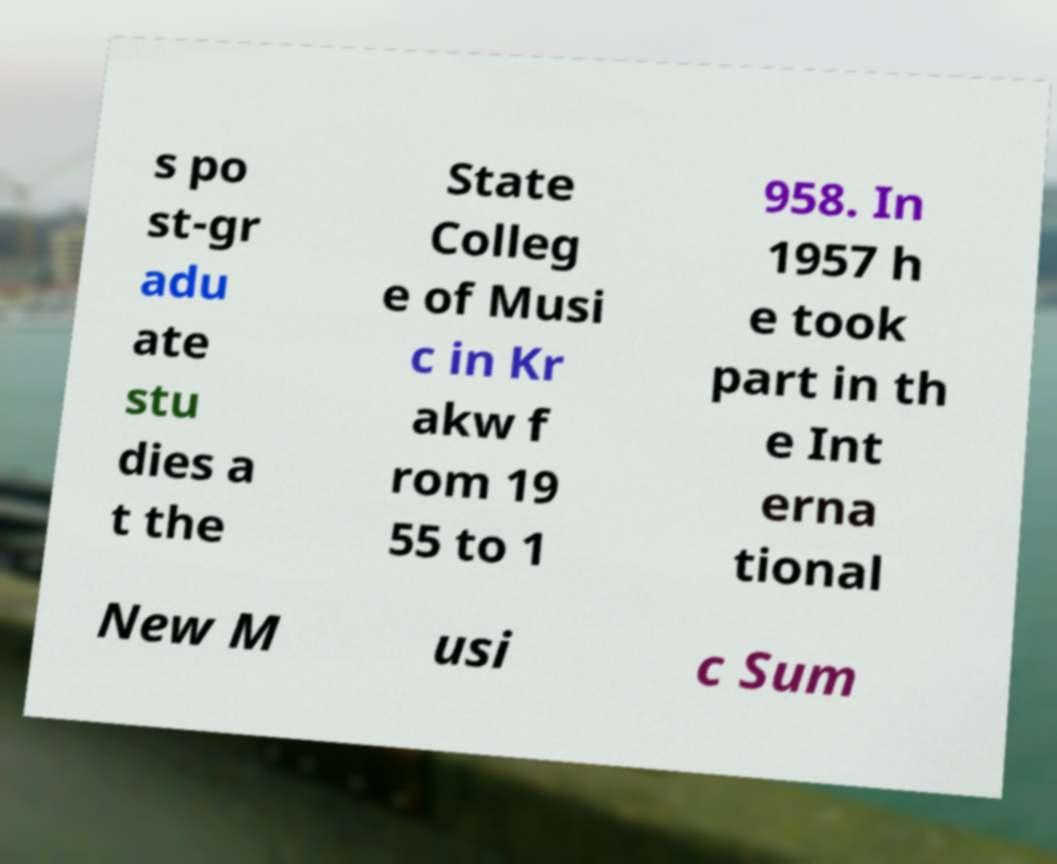For documentation purposes, I need the text within this image transcribed. Could you provide that? s po st-gr adu ate stu dies a t the State Colleg e of Musi c in Kr akw f rom 19 55 to 1 958. In 1957 h e took part in th e Int erna tional New M usi c Sum 